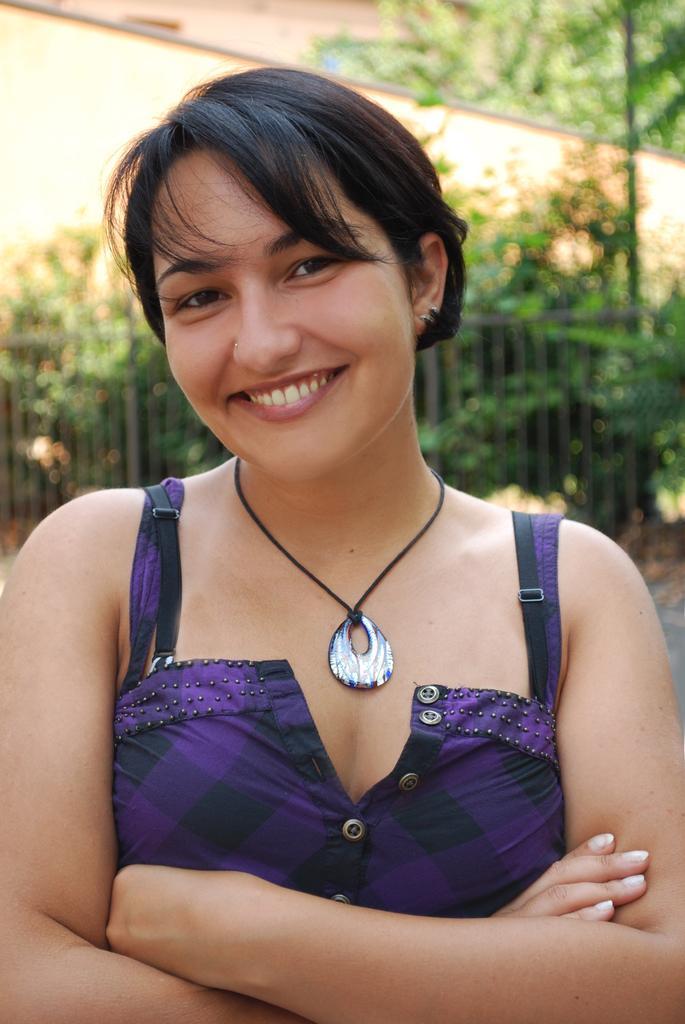Can you describe this image briefly? In the image we can see there is a woman and she is wearing necklace. Behind there are trees and there is a clear sky. Background of the image is little blurred. 